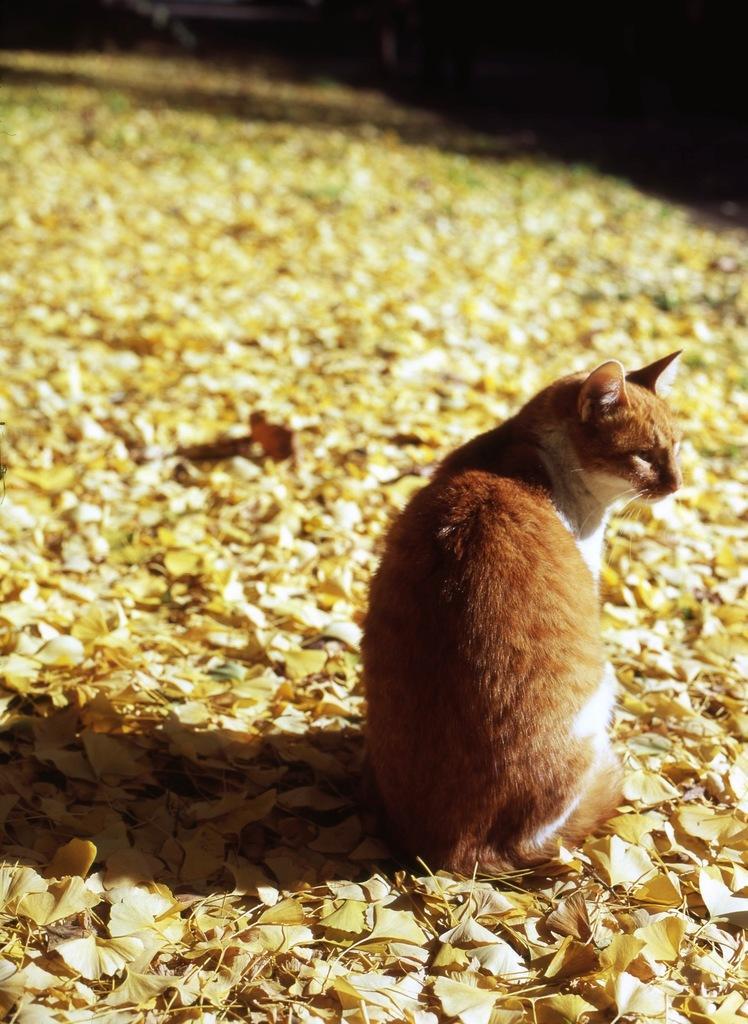Can you describe this image briefly? In this image there is a cat sitting on the leaves. 